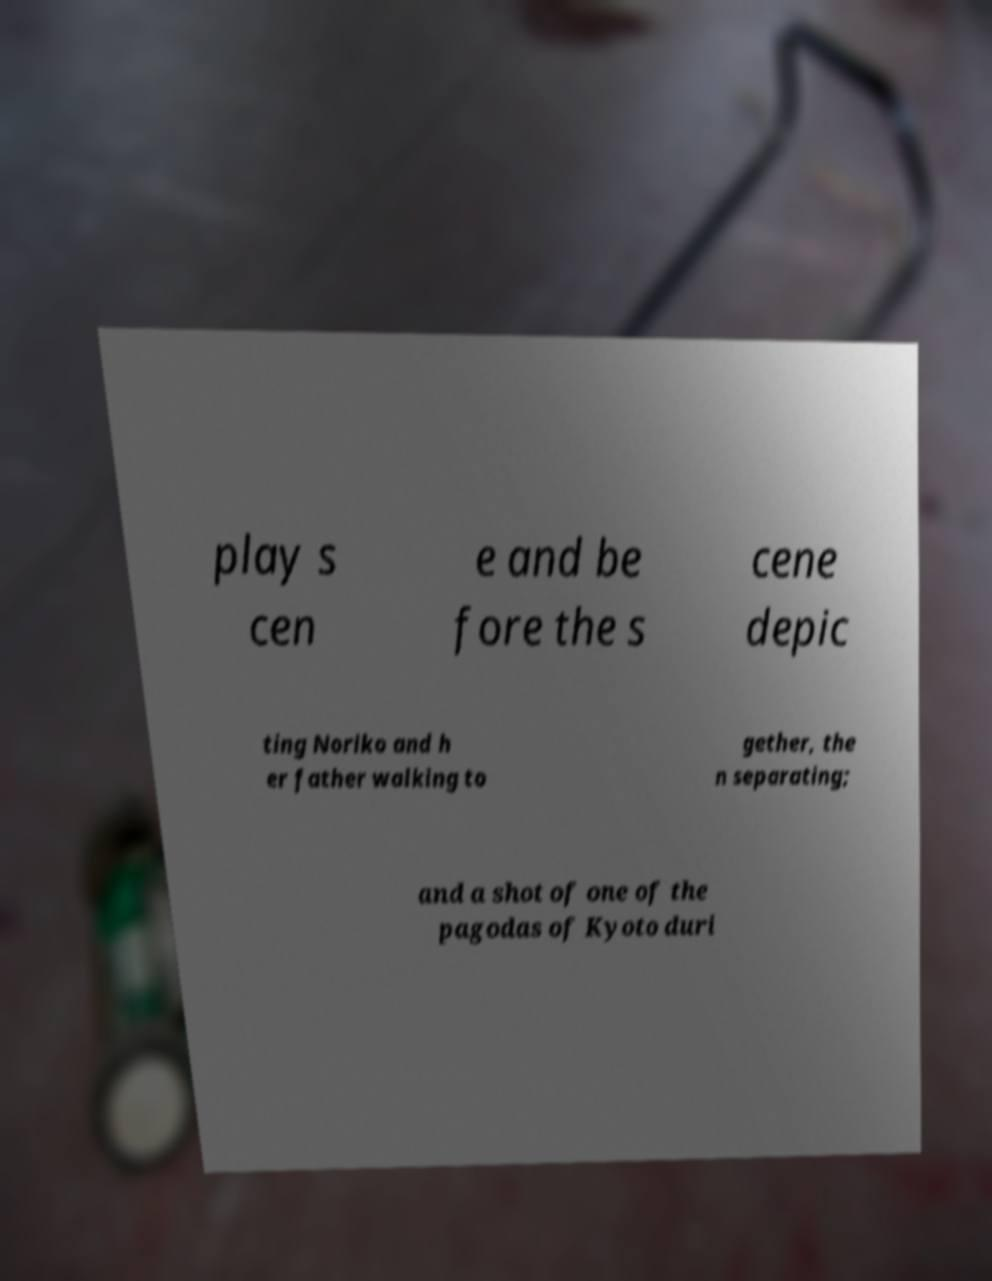Could you assist in decoding the text presented in this image and type it out clearly? play s cen e and be fore the s cene depic ting Noriko and h er father walking to gether, the n separating; and a shot of one of the pagodas of Kyoto duri 